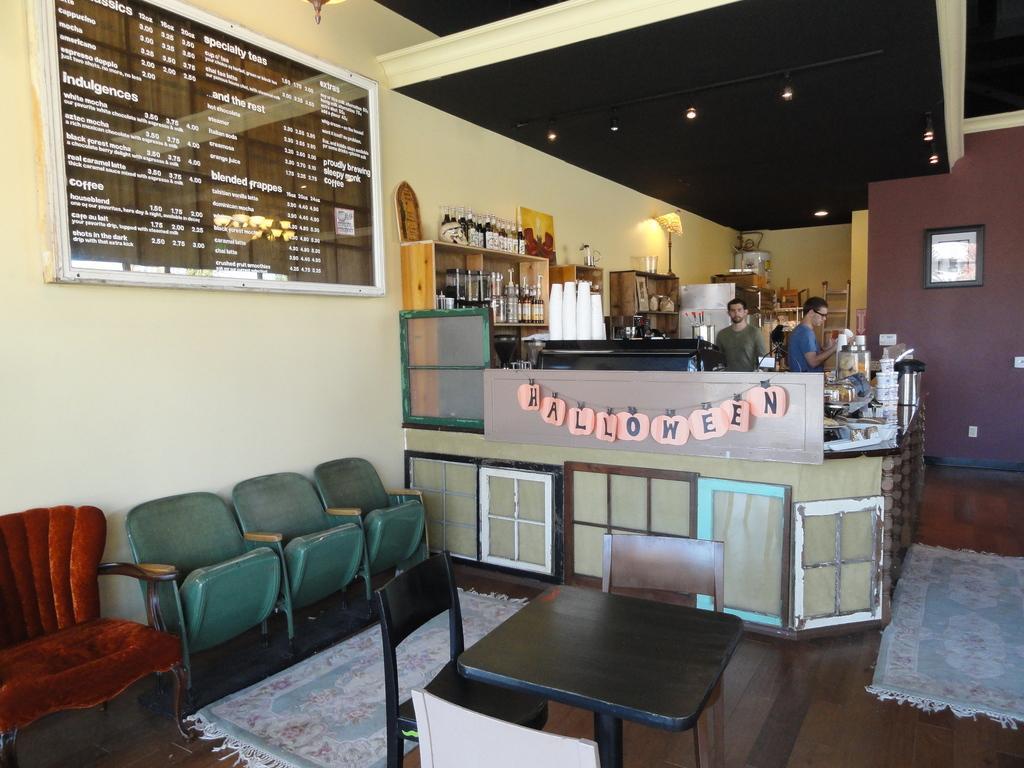In one or two sentences, can you explain what this image depicts? In this image i see chairs, a table, board and 2 men over here. I can also see few things on the countertop, bottles in the racks, cups, wall, a photo frame over here and lights on the ceiling. 